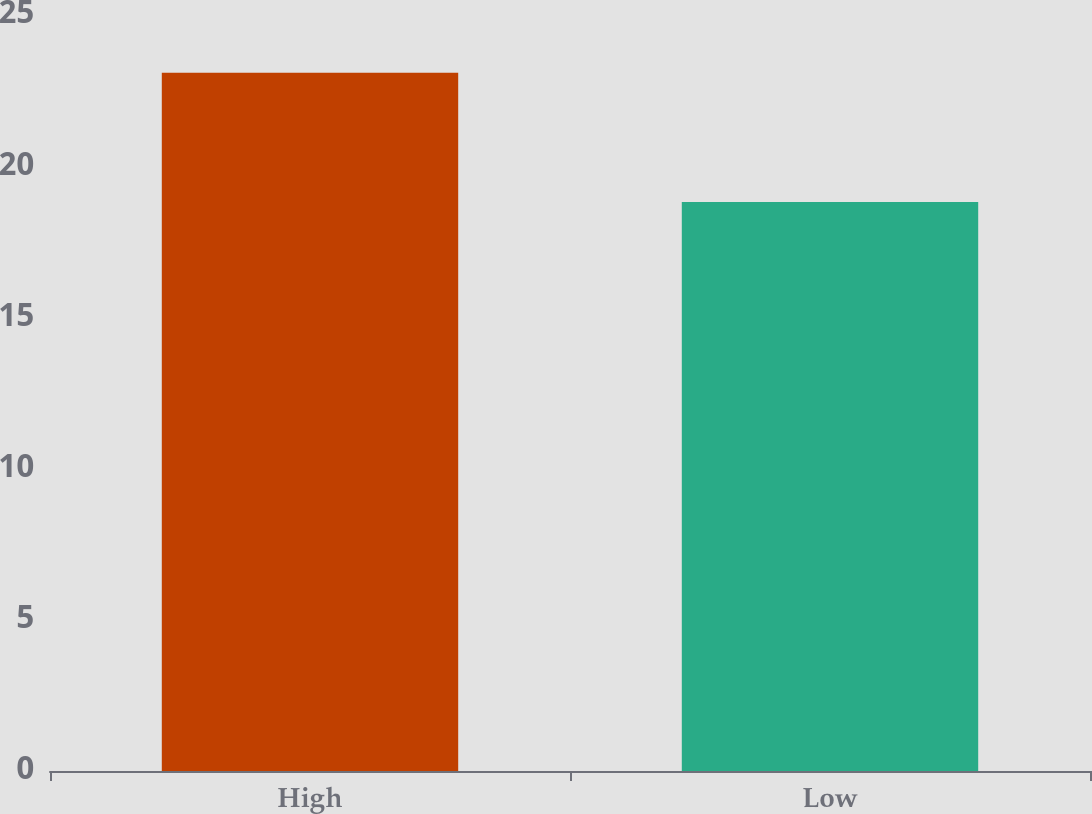<chart> <loc_0><loc_0><loc_500><loc_500><bar_chart><fcel>High<fcel>Low<nl><fcel>23.09<fcel>18.82<nl></chart> 